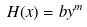<formula> <loc_0><loc_0><loc_500><loc_500>H ( x ) = b y ^ { m }</formula> 